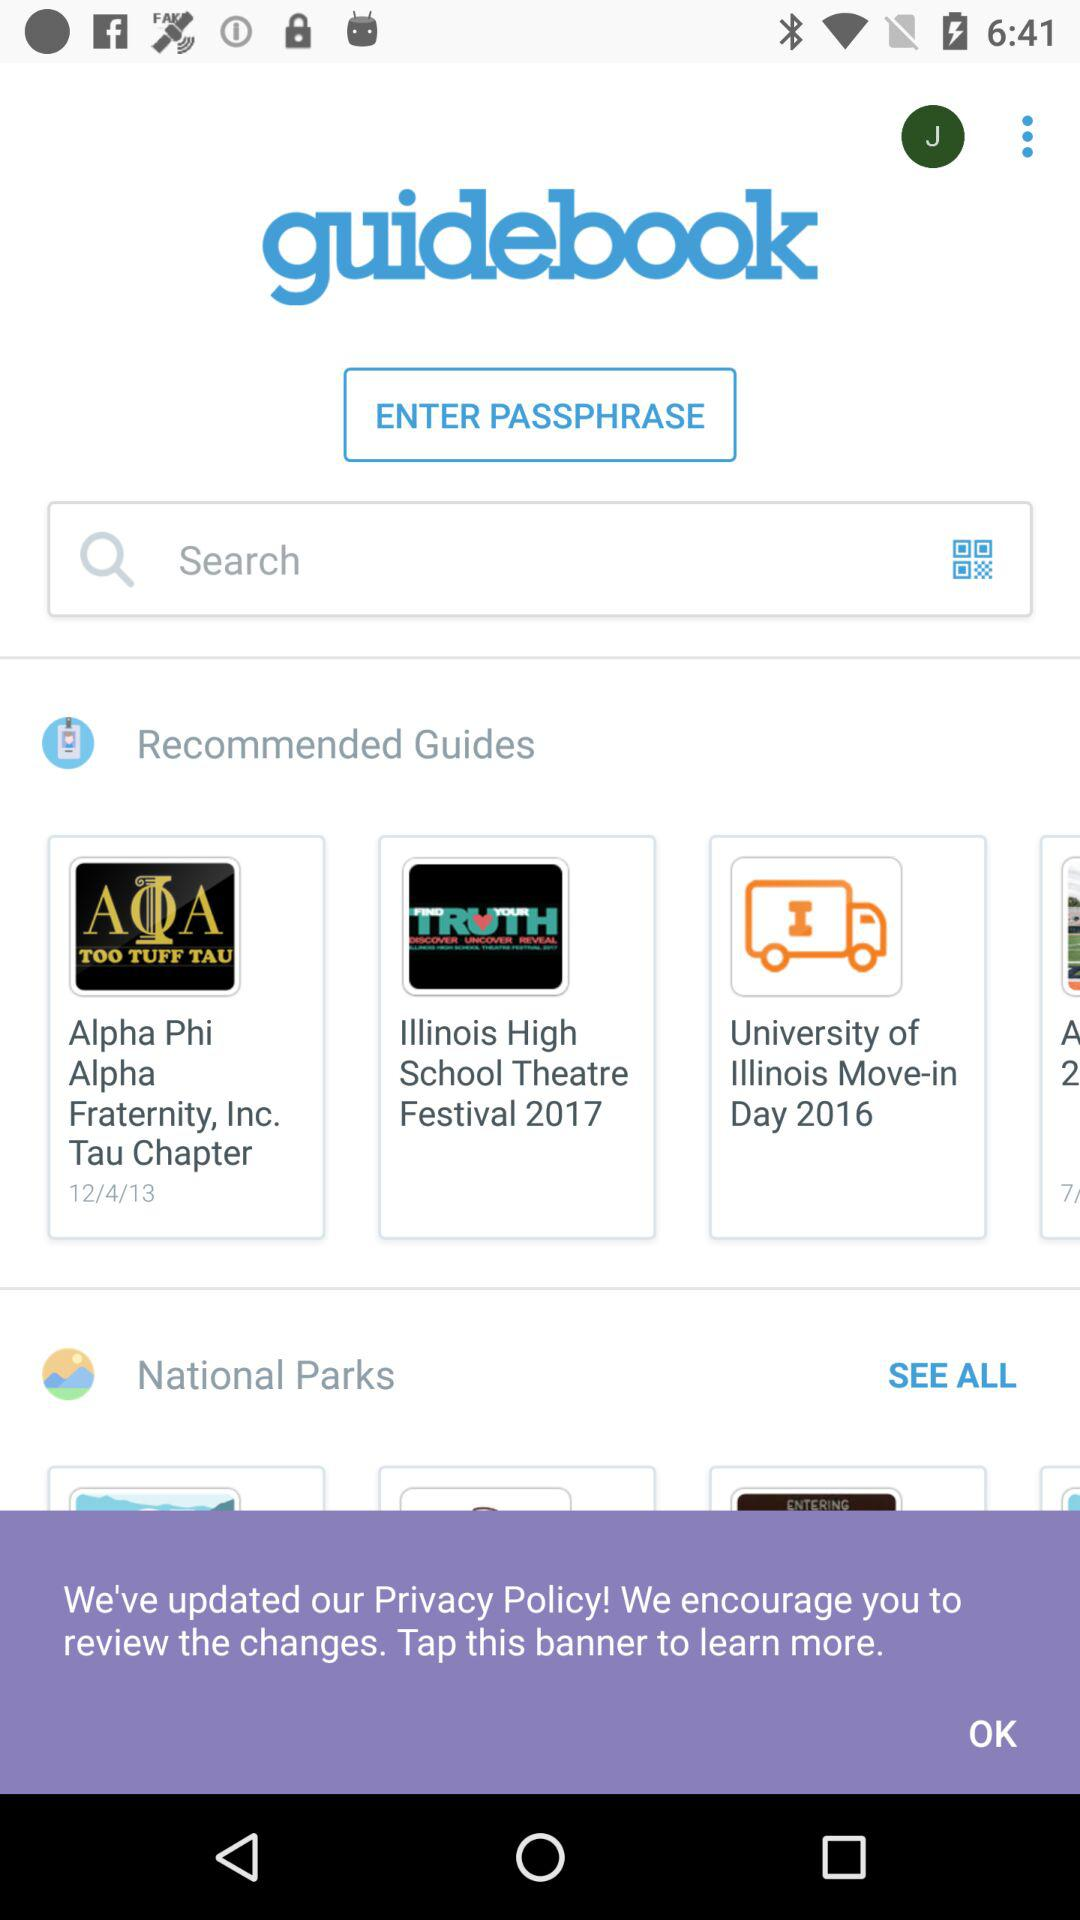Which national parks are shown?
When the provided information is insufficient, respond with <no answer>. <no answer> 